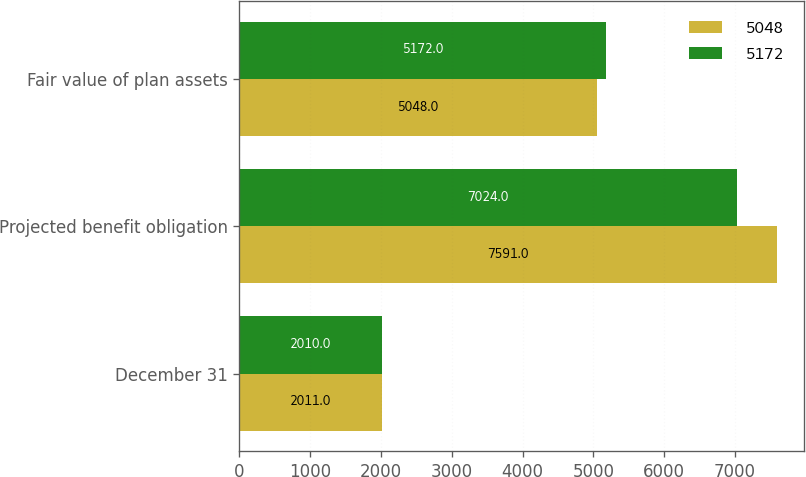Convert chart to OTSL. <chart><loc_0><loc_0><loc_500><loc_500><stacked_bar_chart><ecel><fcel>December 31<fcel>Projected benefit obligation<fcel>Fair value of plan assets<nl><fcel>5048<fcel>2011<fcel>7591<fcel>5048<nl><fcel>5172<fcel>2010<fcel>7024<fcel>5172<nl></chart> 